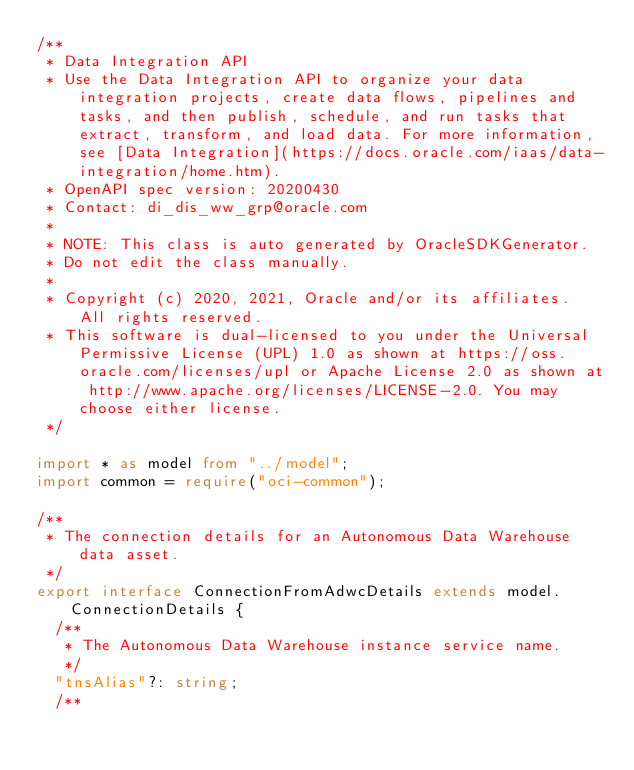<code> <loc_0><loc_0><loc_500><loc_500><_TypeScript_>/**
 * Data Integration API
 * Use the Data Integration API to organize your data integration projects, create data flows, pipelines and tasks, and then publish, schedule, and run tasks that extract, transform, and load data. For more information, see [Data Integration](https://docs.oracle.com/iaas/data-integration/home.htm).
 * OpenAPI spec version: 20200430
 * Contact: di_dis_ww_grp@oracle.com
 *
 * NOTE: This class is auto generated by OracleSDKGenerator.
 * Do not edit the class manually.
 *
 * Copyright (c) 2020, 2021, Oracle and/or its affiliates.  All rights reserved.
 * This software is dual-licensed to you under the Universal Permissive License (UPL) 1.0 as shown at https://oss.oracle.com/licenses/upl or Apache License 2.0 as shown at http://www.apache.org/licenses/LICENSE-2.0. You may choose either license.
 */

import * as model from "../model";
import common = require("oci-common");

/**
 * The connection details for an Autonomous Data Warehouse data asset.
 */
export interface ConnectionFromAdwcDetails extends model.ConnectionDetails {
  /**
   * The Autonomous Data Warehouse instance service name.
   */
  "tnsAlias"?: string;
  /**</code> 